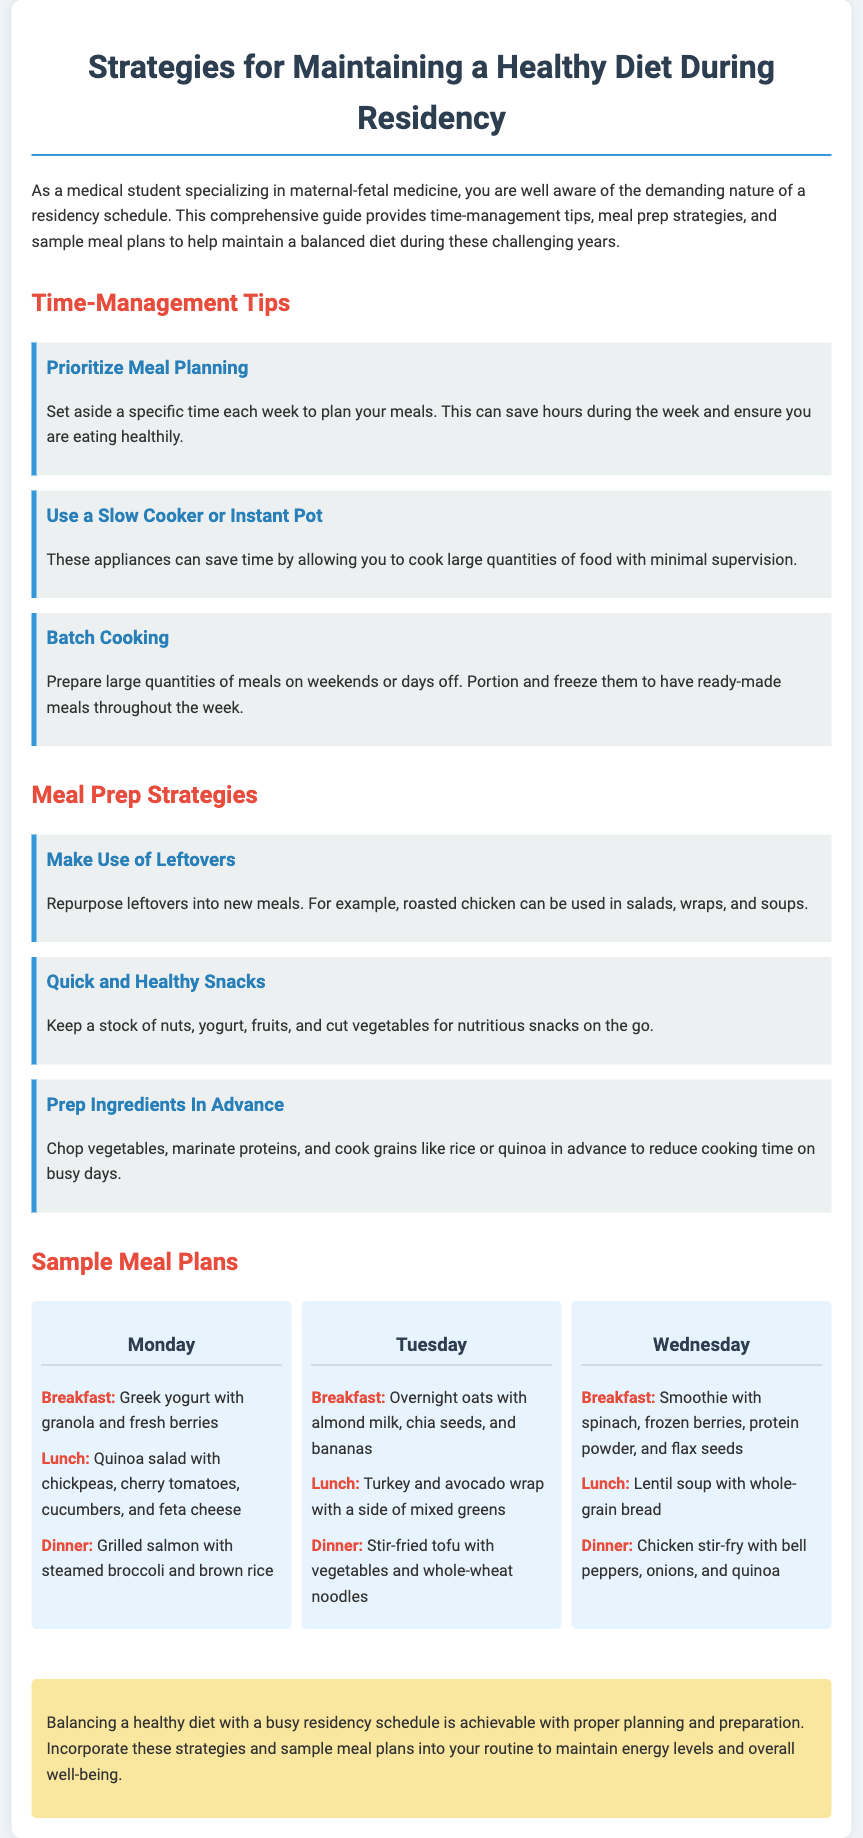What is the title of the document? The title is listed at the top of the document.
Answer: Strategies for Maintaining a Healthy Diet During Residency What appliance is recommended for saving time in meal prep? The document suggests using specific appliances for cooking to save time.
Answer: Slow Cooker or Instant Pot What is a suggested breakfast for Monday? The meal plan provides specific meals for each day, including Monday's breakfast.
Answer: Greek yogurt with granola and fresh berries How many tips are listed under Time-Management Tips? The document provides a counting of tips under the specified section.
Answer: Three What is a healthy snack suggestion mentioned? A strategy section includes recommendations for keeping healthy snacks.
Answer: Nuts What meal type is mentioned for Wednesday's lunch? The meal plan explicitly states the type of meal for Wednesday's lunch.
Answer: Lunch What cooking strategy involves preparing meals in advance on days off? The document provides a specific strategy for meal preparation focusing on time management.
Answer: Batch Cooking Which day features a stir-fried dish for dinner? The document lists the meals for each day, including dinner options.
Answer: Tuesday What is the color of the container background in the document? The document describes the aesthetics, including the background color.
Answer: White 